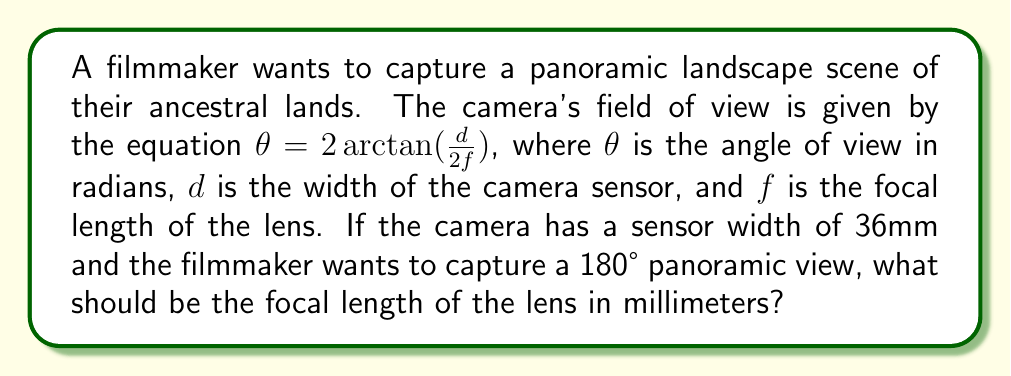Can you solve this math problem? Let's approach this step-by-step:

1) We are given the equation for the field of view:
   $\theta = 2 \arctan(\frac{d}{2f})$

2) We know:
   - $d = 36$ mm (sensor width)
   - $\theta = 180°$ (desired angle of view)

3) First, we need to convert 180° to radians:
   $180° = \pi$ radians

4) Now, let's substitute these values into our equation:
   $\pi = 2 \arctan(\frac{36}{2f})$

5) Simplify the right side:
   $\pi = 2 \arctan(\frac{18}{f})$

6) Divide both sides by 2:
   $\frac{\pi}{2} = \arctan(\frac{18}{f})$

7) Apply the tangent function to both sides:
   $\tan(\frac{\pi}{2}) = \frac{18}{f}$

8) We know that $\tan(\frac{\pi}{2})$ approaches infinity, but in practical terms for a very wide angle, we can approximate it to a very large number, let's say 1,000,000.

9) So our equation becomes:
   $1,000,000 = \frac{18}{f}$

10) Solve for $f$:
    $f = \frac{18}{1,000,000} = 0.000018$ m = 0.018 mm

Therefore, to capture a 180° panoramic view with a 36mm sensor, the focal length should be approximately 0.018 mm.
Answer: 0.018 mm 